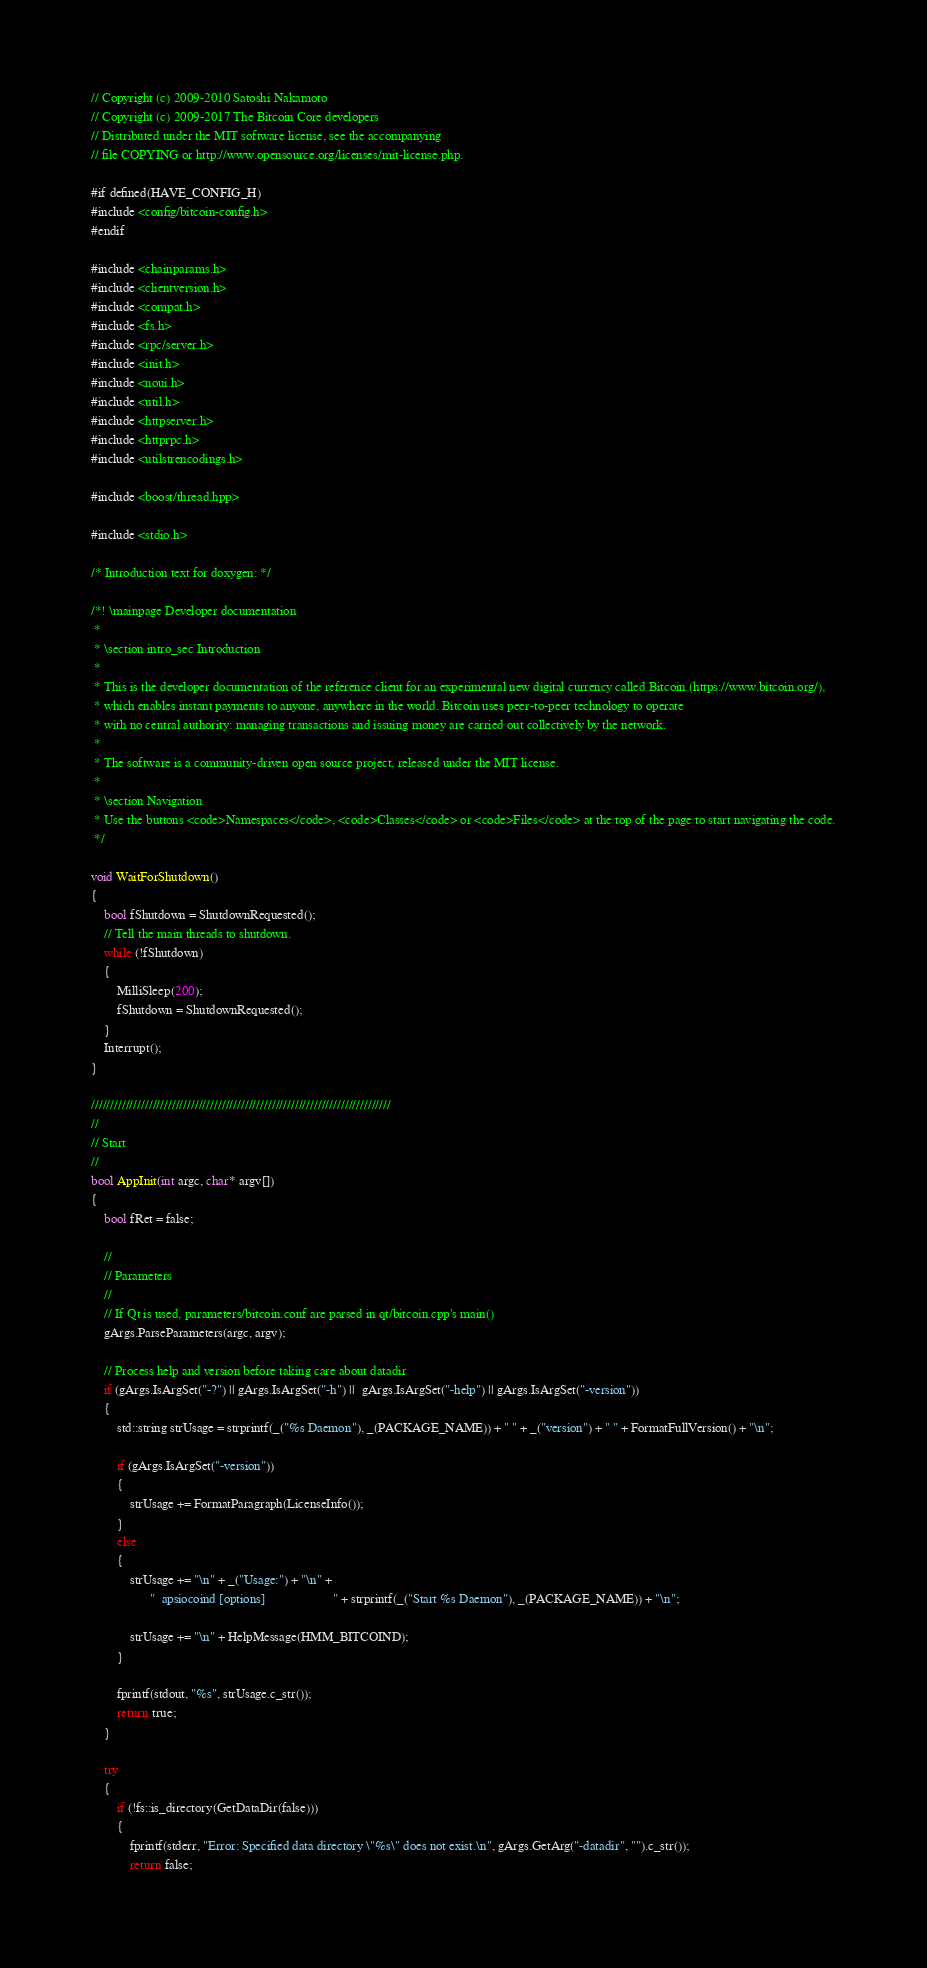Convert code to text. <code><loc_0><loc_0><loc_500><loc_500><_C++_>// Copyright (c) 2009-2010 Satoshi Nakamoto
// Copyright (c) 2009-2017 The Bitcoin Core developers
// Distributed under the MIT software license, see the accompanying
// file COPYING or http://www.opensource.org/licenses/mit-license.php.

#if defined(HAVE_CONFIG_H)
#include <config/bitcoin-config.h>
#endif

#include <chainparams.h>
#include <clientversion.h>
#include <compat.h>
#include <fs.h>
#include <rpc/server.h>
#include <init.h>
#include <noui.h>
#include <util.h>
#include <httpserver.h>
#include <httprpc.h>
#include <utilstrencodings.h>

#include <boost/thread.hpp>

#include <stdio.h>

/* Introduction text for doxygen: */

/*! \mainpage Developer documentation
 *
 * \section intro_sec Introduction
 *
 * This is the developer documentation of the reference client for an experimental new digital currency called Bitcoin (https://www.bitcoin.org/),
 * which enables instant payments to anyone, anywhere in the world. Bitcoin uses peer-to-peer technology to operate
 * with no central authority: managing transactions and issuing money are carried out collectively by the network.
 *
 * The software is a community-driven open source project, released under the MIT license.
 *
 * \section Navigation
 * Use the buttons <code>Namespaces</code>, <code>Classes</code> or <code>Files</code> at the top of the page to start navigating the code.
 */

void WaitForShutdown()
{
    bool fShutdown = ShutdownRequested();
    // Tell the main threads to shutdown.
    while (!fShutdown)
    {
        MilliSleep(200);
        fShutdown = ShutdownRequested();
    }
    Interrupt();
}

//////////////////////////////////////////////////////////////////////////////
//
// Start
//
bool AppInit(int argc, char* argv[])
{
    bool fRet = false;

    //
    // Parameters
    //
    // If Qt is used, parameters/bitcoin.conf are parsed in qt/bitcoin.cpp's main()
    gArgs.ParseParameters(argc, argv);

    // Process help and version before taking care about datadir
    if (gArgs.IsArgSet("-?") || gArgs.IsArgSet("-h") ||  gArgs.IsArgSet("-help") || gArgs.IsArgSet("-version"))
    {
        std::string strUsage = strprintf(_("%s Daemon"), _(PACKAGE_NAME)) + " " + _("version") + " " + FormatFullVersion() + "\n";

        if (gArgs.IsArgSet("-version"))
        {
            strUsage += FormatParagraph(LicenseInfo());
        }
        else
        {
            strUsage += "\n" + _("Usage:") + "\n" +
                  "  apsiocoind [options]                     " + strprintf(_("Start %s Daemon"), _(PACKAGE_NAME)) + "\n";

            strUsage += "\n" + HelpMessage(HMM_BITCOIND);
        }

        fprintf(stdout, "%s", strUsage.c_str());
        return true;
    }

    try
    {
        if (!fs::is_directory(GetDataDir(false)))
        {
            fprintf(stderr, "Error: Specified data directory \"%s\" does not exist.\n", gArgs.GetArg("-datadir", "").c_str());
            return false;</code> 